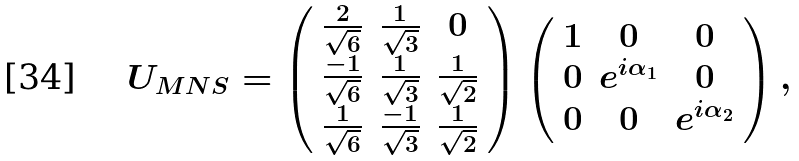Convert formula to latex. <formula><loc_0><loc_0><loc_500><loc_500>U _ { M N S } = \left ( \begin{array} { c c c } \frac { 2 } { \sqrt { 6 } } & \frac { 1 } { \sqrt { 3 } } & 0 \\ \frac { - 1 } { \sqrt { 6 } } & \frac { 1 } { \sqrt { 3 } } & \frac { 1 } { \sqrt { 2 } } \\ \frac { 1 } { \sqrt { 6 } } & \frac { - 1 } { \sqrt { 3 } } & \frac { 1 } { \sqrt { 2 } } \\ \end{array} \right ) \left ( \begin{array} { c c c } 1 & 0 & 0 \\ 0 & e ^ { i \alpha _ { 1 } } & 0 \\ 0 & 0 & e ^ { i \alpha _ { 2 } } \\ \end{array} \right ) ,</formula> 